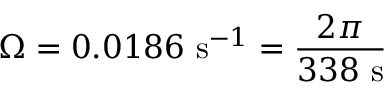Convert formula to latex. <formula><loc_0><loc_0><loc_500><loc_500>\Omega = 0 . 0 1 8 6 \ s ^ { - 1 } = { \frac { 2 \pi } { 3 3 8 \ s } }</formula> 